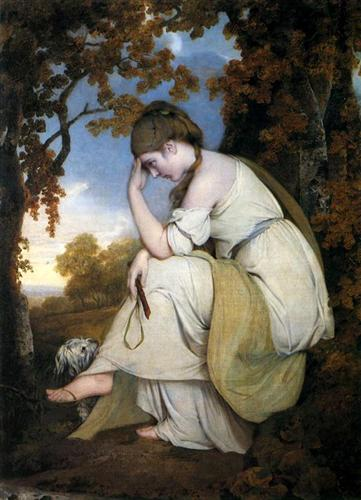Based on the woman's attire and surroundings, imagine a historical context for this scene. Provide a short explanation. This painting appears to depict a scene from the early 19th century, a time when Romanticism profoundly influenced art and culture. The young woman's attire, a simple yet elegant white dress, reflects the period's fashion, emphasizing natural beauty and emotional expression. The wooded setting, with its warm, earthy tones, highlights the Romantic era's fascination with nature and the sublime. The woman's contemplative pose suggests a moment of personal reflection or emotional depth, common themes in Romantic art, which sought to capture the complex interplay between human emotion and the natural world. 